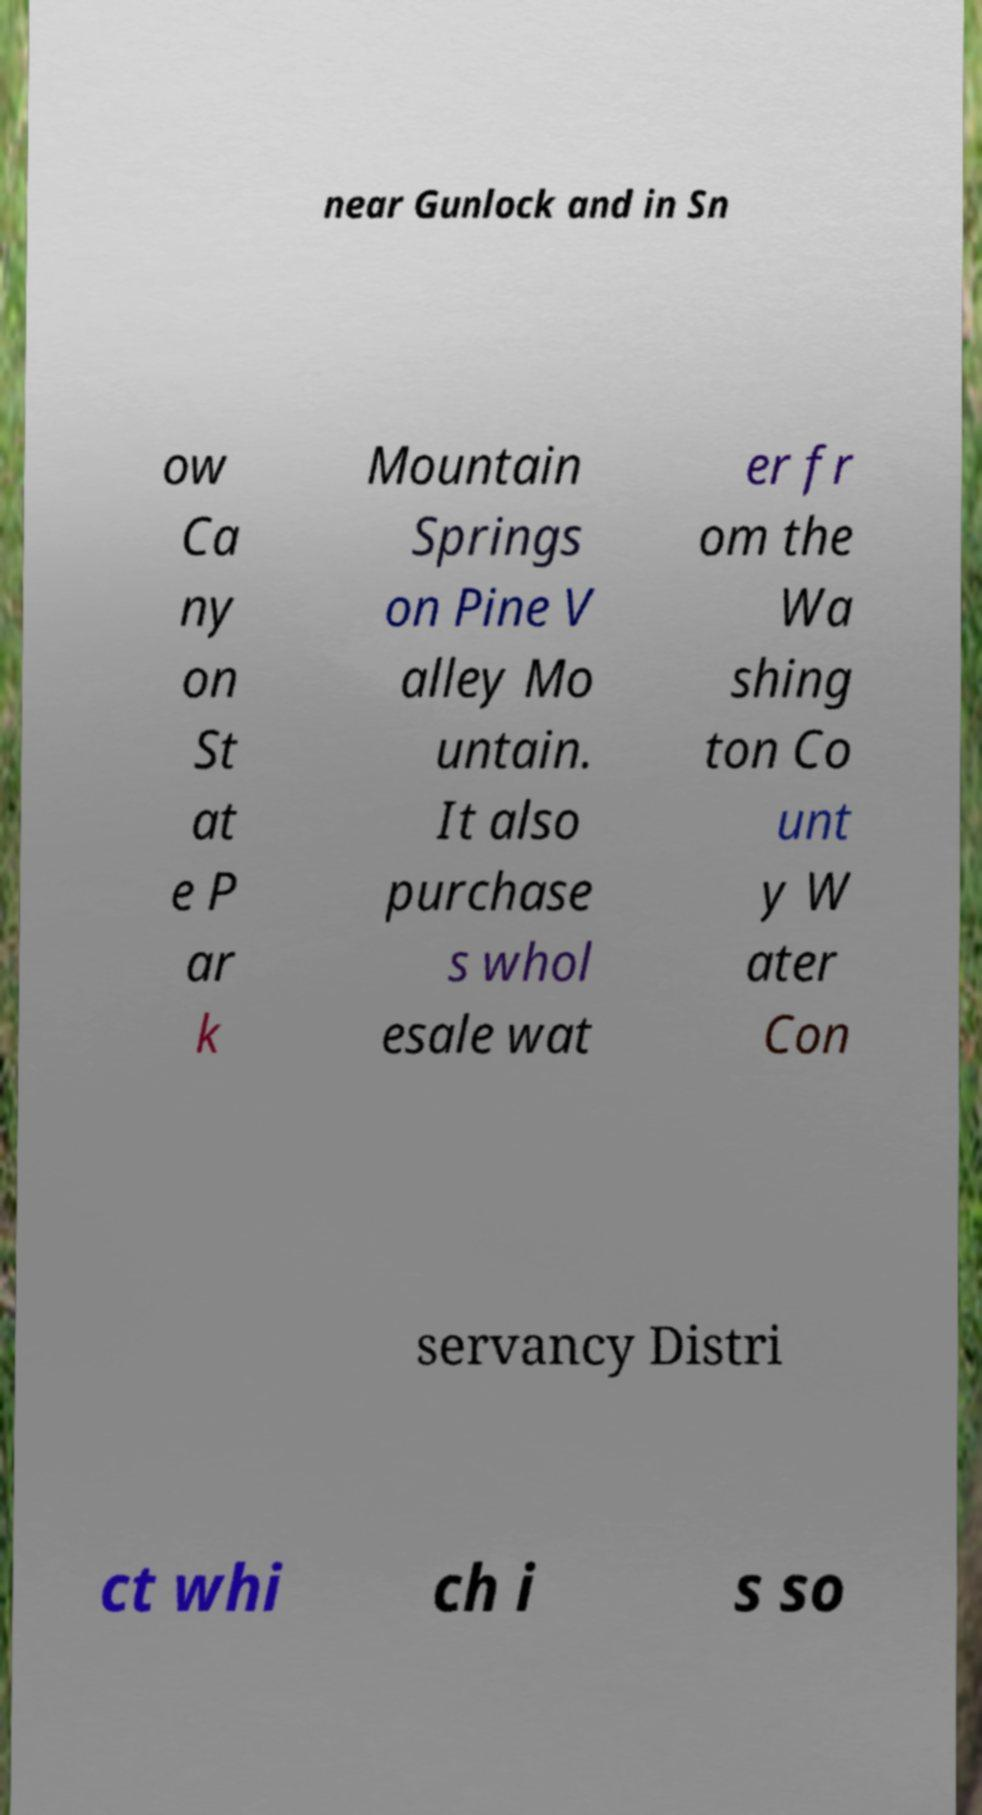Can you accurately transcribe the text from the provided image for me? near Gunlock and in Sn ow Ca ny on St at e P ar k Mountain Springs on Pine V alley Mo untain. It also purchase s whol esale wat er fr om the Wa shing ton Co unt y W ater Con servancy Distri ct whi ch i s so 